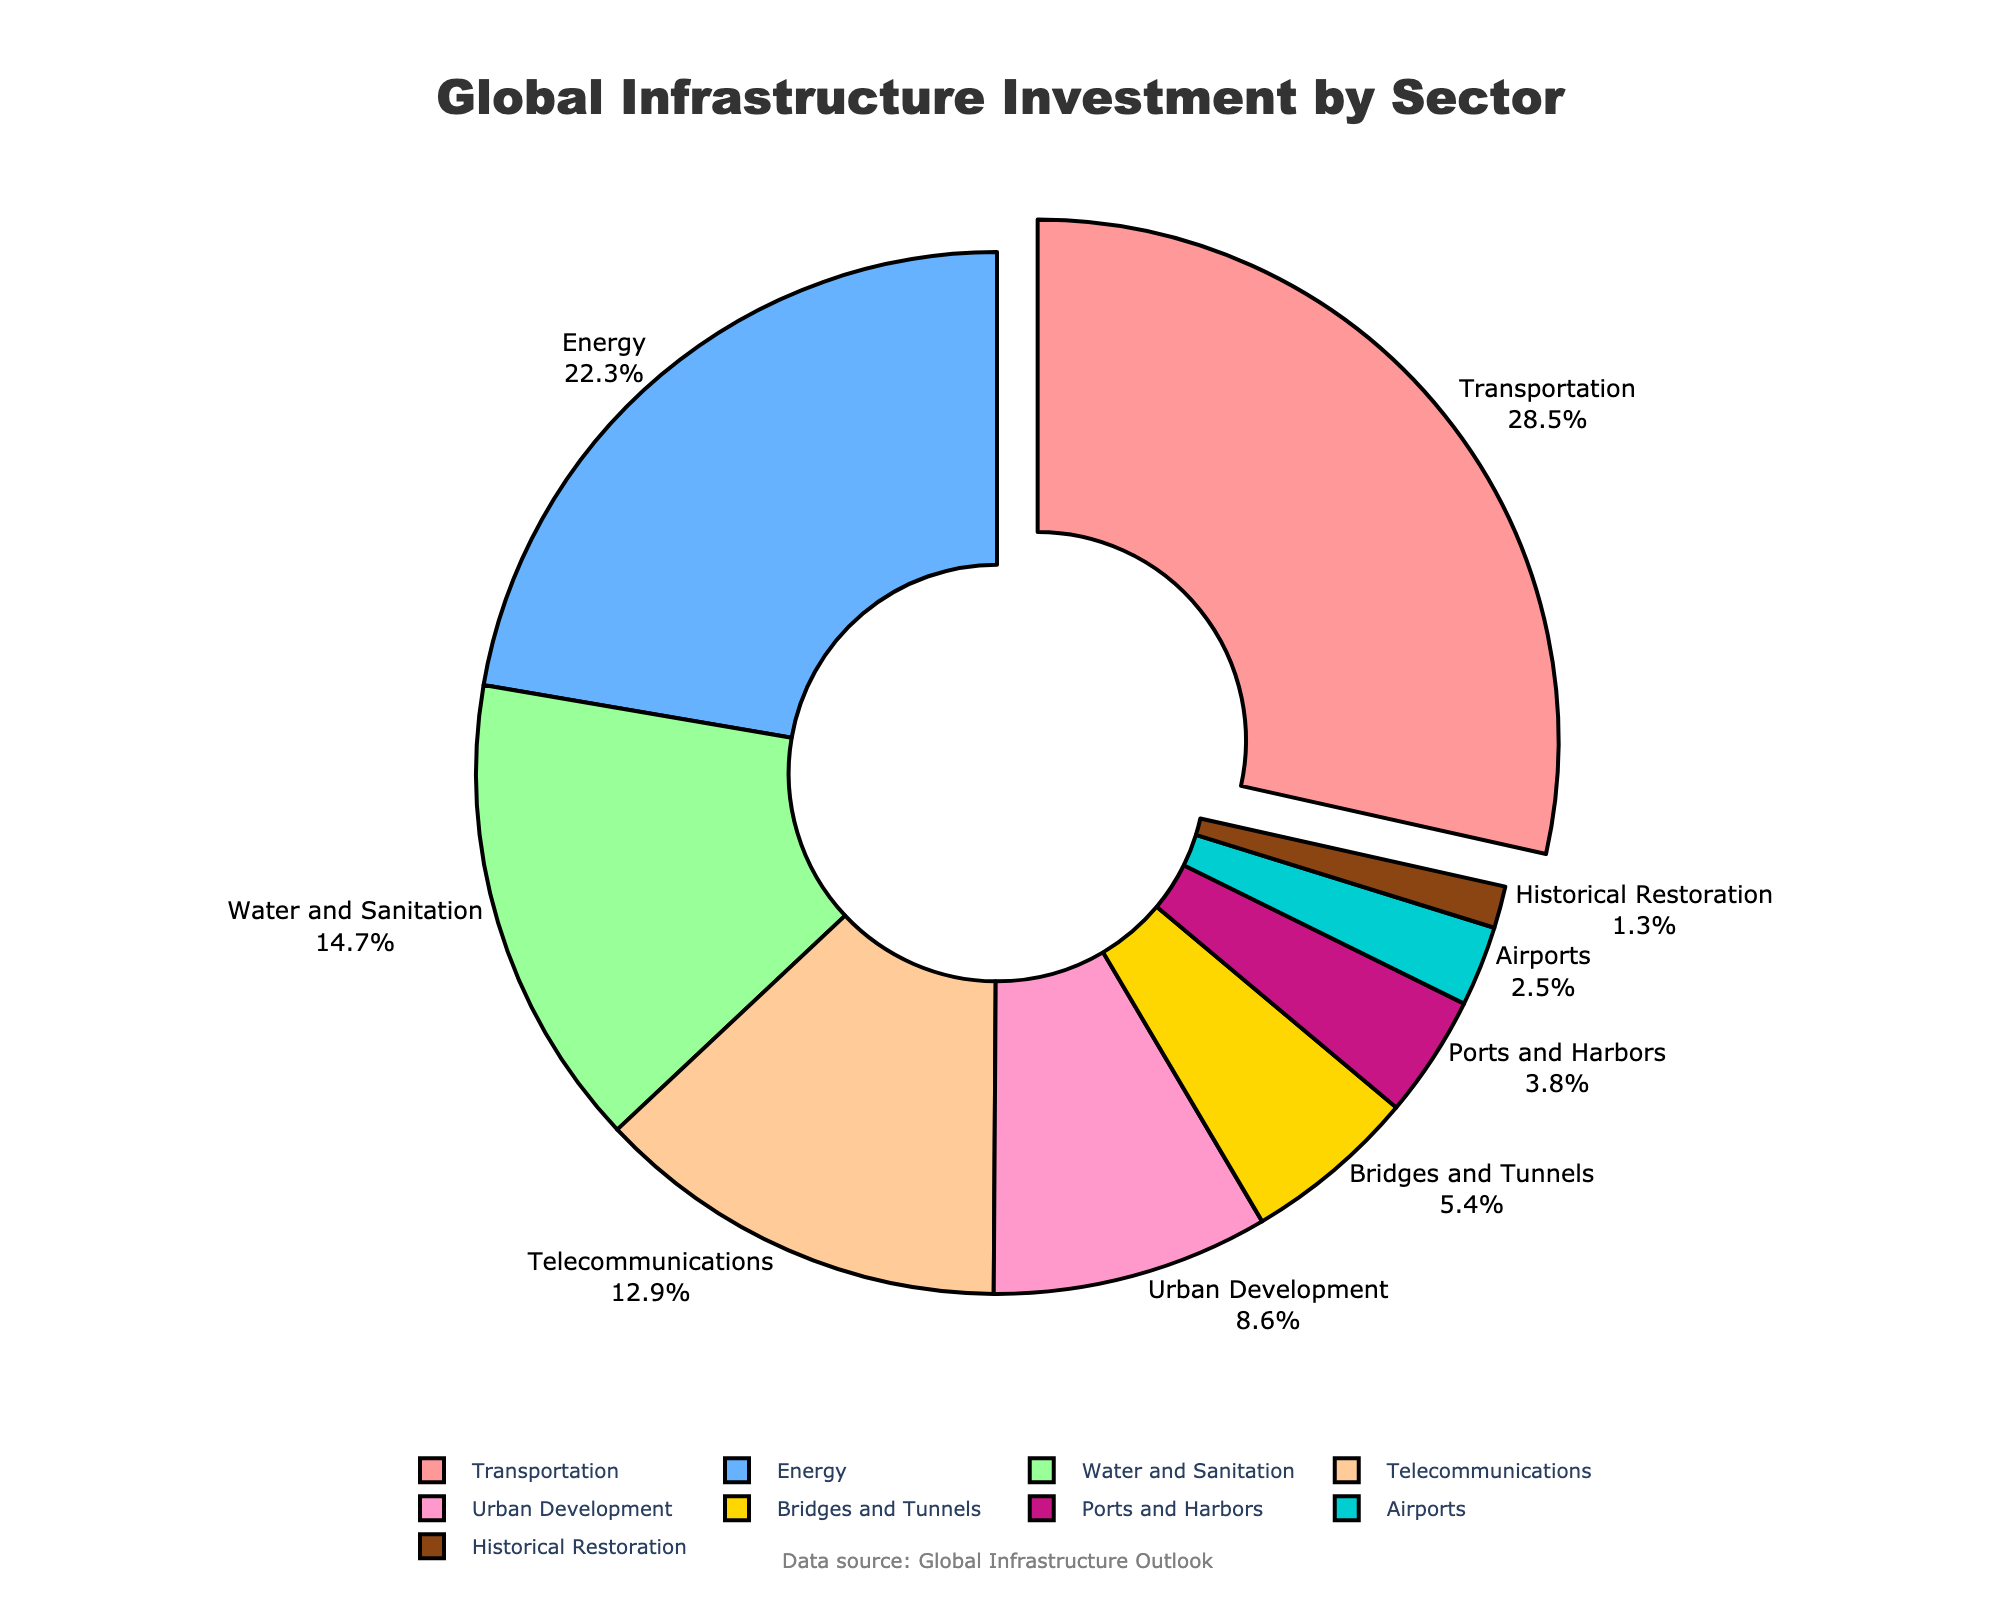What sector has the highest investment percentage? We can see from the pie chart that the sector with the highest investment percentage is "Transportation." It's emphasized by being slightly pulled out and displays the highest percentage.
Answer: Transportation Which sectors have an investment percentage greater than 20%? Looking at the pie chart, both "Transportation" and "Energy" have investment percentages greater than 20%. Transportation has 28.5% and Energy has 22.3%.
Answer: Transportation and Energy What is the combined investment percentage for Water and Sanitation, Telecommunications, and Urban Development? Adding the investment percentages for Water and Sanitation (14.7%), Telecommunications (12.9%), and Urban Development (8.6%):
14.7 + 12.9 + 8.6 = 36.2%
Answer: 36.2% Which sector has the smallest investment percentage and what is it? Observing the pie chart, "Historical Restoration" is the smallest segment with an investment percentage of 1.3%.
Answer: Historical Restoration How does the investment in Ports and Harbors compare to that in Airports? From the chart, Ports and Harbors have an investment percentage of 3.8%, while Airports have 2.5%. So, Ports and Harbors have a higher percentage.
Answer: Ports and Harbors have a higher percentage than Airports What's the total investment percentage for infrastructure sectors related to transport (Transportation, Airports, Ports and Harbors)? Summing the percentages for Transportation (28.5%), Airports (2.5%), and Ports and Harbors (3.8%):
28.5 + 2.5 + 3.8 = 34.8%
Answer: 34.8% Identify and describe the color associated with the "Energy" sector from the pie chart. In the pie chart, the "Energy" sector is represented by a blue segment.
Answer: Blue What is the difference in investment percentage between the "Bridges and Tunnels" and "Urban Development" sectors? The Bridges and Tunnels sector has an investment percentage of 5.4%, while Urban Development has 8.6%. The difference is:
8.6 - 5.4 = 3.2%
Answer: 3.2% Is the investment in Water and Sanitation more or less than 15%? From the pie chart, the investment percentage for Water and Sanitation is 14.7%, which is slightly less than 15%.
Answer: Less than 15% Which sectors combined make up close to half (50%) of the total investment percentage? Summing the percentages of the largest sectors until we reach close to 50%: 
Transportation (28.5%) + Energy (22.3%) = 50.8%
Since these two already exceed, checking lower combinations:
Transportation (28.5%) + Water and Sanitation (14.7%) + Telecommunications (12.9%) = 56.1% 
Continuing until acceptable:
Transportation (28.5%) + Energy (22.3%) = 50.8%
Answer: Transportation and Energy 